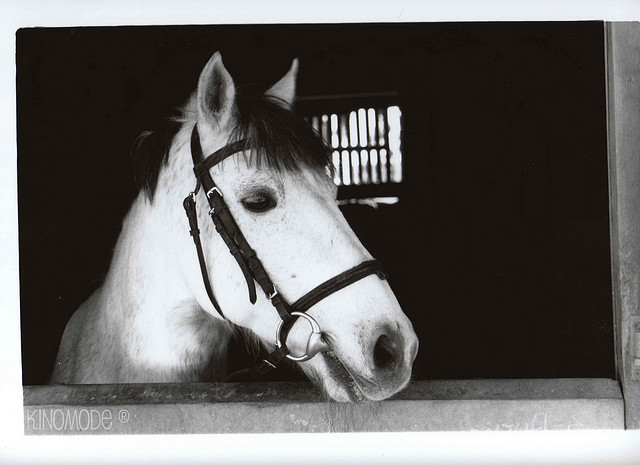Please identify all text content in this image. KINOMODE R 